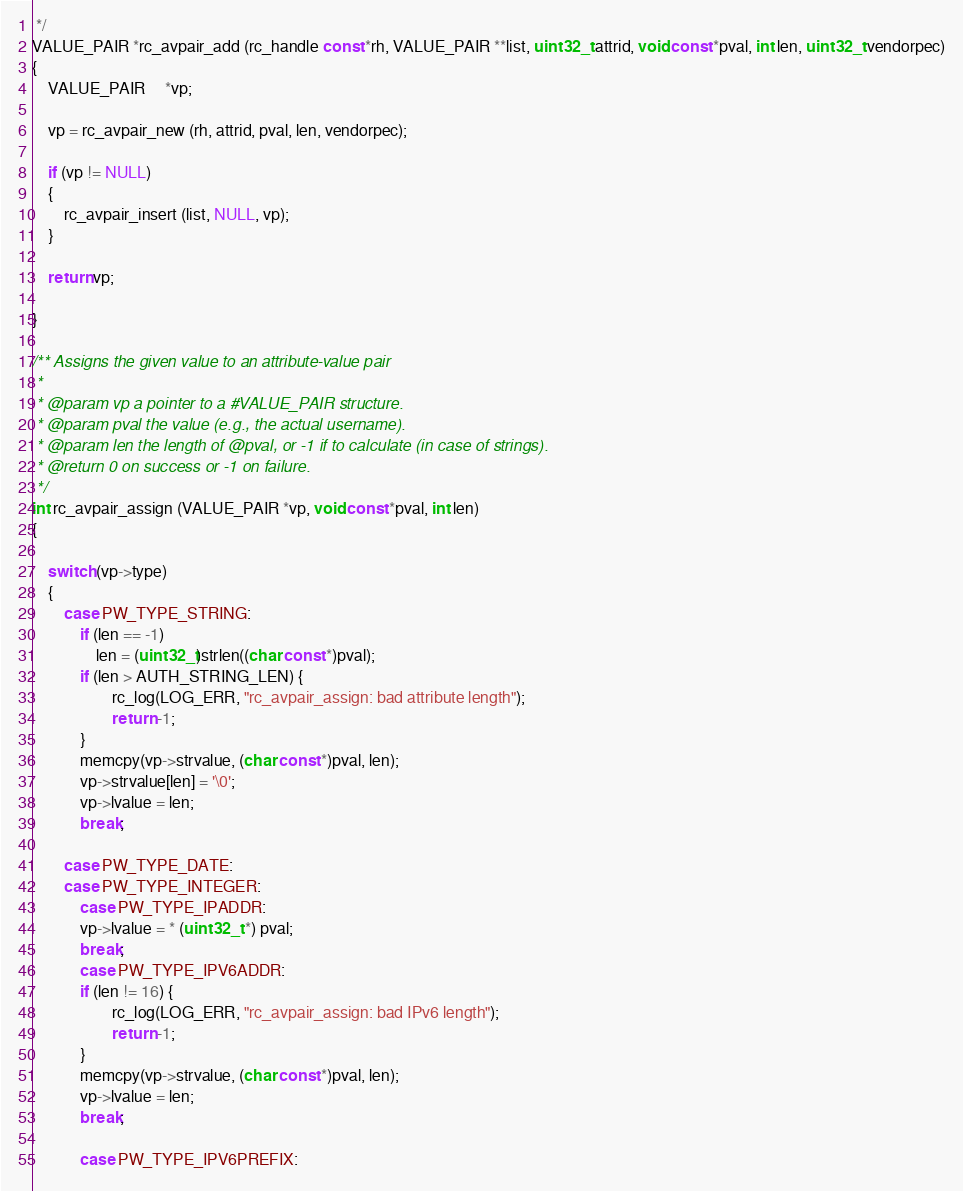<code> <loc_0><loc_0><loc_500><loc_500><_C_> */
VALUE_PAIR *rc_avpair_add (rc_handle const *rh, VALUE_PAIR **list, uint32_t attrid, void const *pval, int len, uint32_t vendorpec)
{
	VALUE_PAIR     *vp;

	vp = rc_avpair_new (rh, attrid, pval, len, vendorpec);

	if (vp != NULL)
	{
		rc_avpair_insert (list, NULL, vp);
	}

	return vp;

}

/** Assigns the given value to an attribute-value pair
 *
 * @param vp a pointer to a #VALUE_PAIR structure.
 * @param pval the value (e.g., the actual username).
 * @param len the length of @pval, or -1 if to calculate (in case of strings).
 * @return 0 on success or -1 on failure.
 */
int rc_avpair_assign (VALUE_PAIR *vp, void const *pval, int len)
{

	switch (vp->type)
	{
		case PW_TYPE_STRING:
			if (len == -1)
				len = (uint32_t)strlen((char const *)pval);
			if (len > AUTH_STRING_LEN) {
		        	rc_log(LOG_ERR, "rc_avpair_assign: bad attribute length");
		        	return -1;
			}
			memcpy(vp->strvalue, (char const *)pval, len);
			vp->strvalue[len] = '\0';
			vp->lvalue = len;
			break;

		case PW_TYPE_DATE:
		case PW_TYPE_INTEGER:
	        case PW_TYPE_IPADDR:
			vp->lvalue = * (uint32_t *) pval;
			break;
	        case PW_TYPE_IPV6ADDR:
			if (len != 16) {
		        	rc_log(LOG_ERR, "rc_avpair_assign: bad IPv6 length");
		        	return -1;
			}
			memcpy(vp->strvalue, (char const *)pval, len);
			vp->lvalue = len;
			break;

	        case PW_TYPE_IPV6PREFIX:</code> 